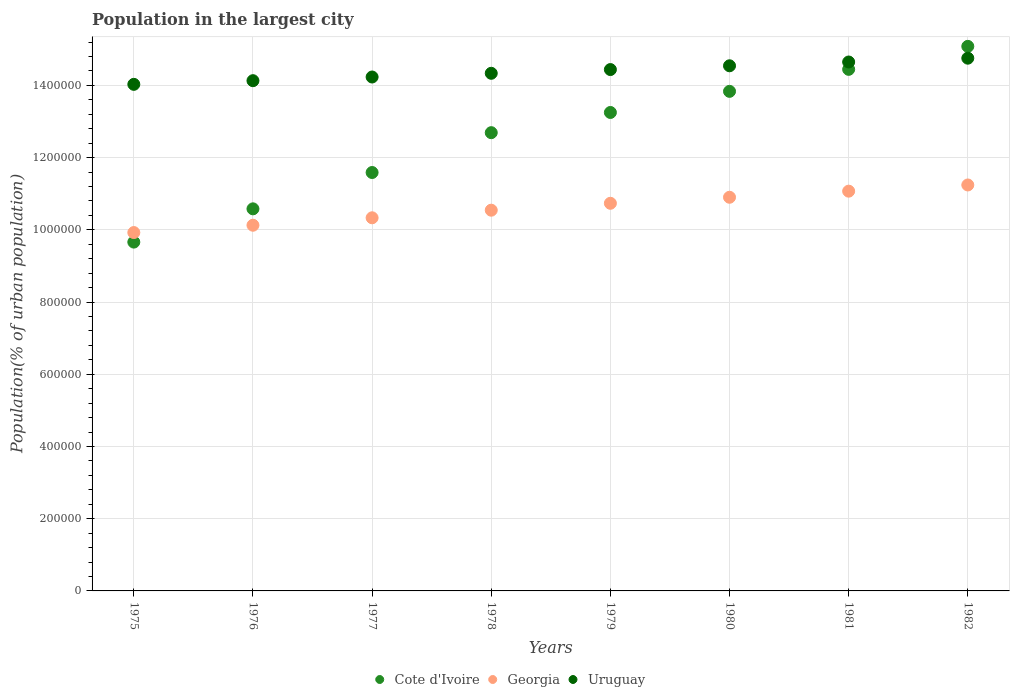How many different coloured dotlines are there?
Your answer should be very brief. 3. What is the population in the largest city in Cote d'Ivoire in 1977?
Offer a terse response. 1.16e+06. Across all years, what is the maximum population in the largest city in Georgia?
Keep it short and to the point. 1.12e+06. Across all years, what is the minimum population in the largest city in Georgia?
Keep it short and to the point. 9.92e+05. In which year was the population in the largest city in Cote d'Ivoire maximum?
Provide a succinct answer. 1982. In which year was the population in the largest city in Cote d'Ivoire minimum?
Ensure brevity in your answer.  1975. What is the total population in the largest city in Georgia in the graph?
Make the answer very short. 8.49e+06. What is the difference between the population in the largest city in Cote d'Ivoire in 1977 and that in 1980?
Offer a terse response. -2.25e+05. What is the difference between the population in the largest city in Cote d'Ivoire in 1979 and the population in the largest city in Georgia in 1975?
Offer a terse response. 3.33e+05. What is the average population in the largest city in Cote d'Ivoire per year?
Offer a terse response. 1.26e+06. In the year 1975, what is the difference between the population in the largest city in Cote d'Ivoire and population in the largest city in Georgia?
Your answer should be compact. -2.64e+04. What is the ratio of the population in the largest city in Uruguay in 1979 to that in 1980?
Offer a very short reply. 0.99. What is the difference between the highest and the second highest population in the largest city in Cote d'Ivoire?
Provide a short and direct response. 6.37e+04. What is the difference between the highest and the lowest population in the largest city in Georgia?
Provide a succinct answer. 1.32e+05. In how many years, is the population in the largest city in Cote d'Ivoire greater than the average population in the largest city in Cote d'Ivoire taken over all years?
Give a very brief answer. 5. Is the sum of the population in the largest city in Uruguay in 1975 and 1980 greater than the maximum population in the largest city in Georgia across all years?
Offer a very short reply. Yes. Is it the case that in every year, the sum of the population in the largest city in Cote d'Ivoire and population in the largest city in Uruguay  is greater than the population in the largest city in Georgia?
Your answer should be very brief. Yes. Does the population in the largest city in Uruguay monotonically increase over the years?
Offer a very short reply. Yes. Is the population in the largest city in Uruguay strictly greater than the population in the largest city in Cote d'Ivoire over the years?
Provide a short and direct response. No. How many years are there in the graph?
Make the answer very short. 8. Does the graph contain any zero values?
Offer a terse response. No. Does the graph contain grids?
Your answer should be compact. Yes. Where does the legend appear in the graph?
Offer a terse response. Bottom center. What is the title of the graph?
Provide a short and direct response. Population in the largest city. What is the label or title of the Y-axis?
Provide a short and direct response. Population(% of urban population). What is the Population(% of urban population) in Cote d'Ivoire in 1975?
Keep it short and to the point. 9.66e+05. What is the Population(% of urban population) of Georgia in 1975?
Keep it short and to the point. 9.92e+05. What is the Population(% of urban population) of Uruguay in 1975?
Provide a succinct answer. 1.40e+06. What is the Population(% of urban population) of Cote d'Ivoire in 1976?
Your answer should be very brief. 1.06e+06. What is the Population(% of urban population) in Georgia in 1976?
Keep it short and to the point. 1.01e+06. What is the Population(% of urban population) of Uruguay in 1976?
Your answer should be compact. 1.41e+06. What is the Population(% of urban population) in Cote d'Ivoire in 1977?
Provide a succinct answer. 1.16e+06. What is the Population(% of urban population) of Georgia in 1977?
Give a very brief answer. 1.03e+06. What is the Population(% of urban population) in Uruguay in 1977?
Your answer should be compact. 1.42e+06. What is the Population(% of urban population) in Cote d'Ivoire in 1978?
Provide a short and direct response. 1.27e+06. What is the Population(% of urban population) of Georgia in 1978?
Offer a very short reply. 1.05e+06. What is the Population(% of urban population) in Uruguay in 1978?
Ensure brevity in your answer.  1.43e+06. What is the Population(% of urban population) in Cote d'Ivoire in 1979?
Provide a succinct answer. 1.33e+06. What is the Population(% of urban population) of Georgia in 1979?
Your response must be concise. 1.07e+06. What is the Population(% of urban population) of Uruguay in 1979?
Ensure brevity in your answer.  1.44e+06. What is the Population(% of urban population) of Cote d'Ivoire in 1980?
Your response must be concise. 1.38e+06. What is the Population(% of urban population) in Georgia in 1980?
Offer a terse response. 1.09e+06. What is the Population(% of urban population) of Uruguay in 1980?
Give a very brief answer. 1.45e+06. What is the Population(% of urban population) in Cote d'Ivoire in 1981?
Provide a succinct answer. 1.44e+06. What is the Population(% of urban population) in Georgia in 1981?
Your answer should be compact. 1.11e+06. What is the Population(% of urban population) in Uruguay in 1981?
Keep it short and to the point. 1.46e+06. What is the Population(% of urban population) of Cote d'Ivoire in 1982?
Your answer should be very brief. 1.51e+06. What is the Population(% of urban population) of Georgia in 1982?
Offer a very short reply. 1.12e+06. What is the Population(% of urban population) of Uruguay in 1982?
Keep it short and to the point. 1.48e+06. Across all years, what is the maximum Population(% of urban population) in Cote d'Ivoire?
Your response must be concise. 1.51e+06. Across all years, what is the maximum Population(% of urban population) in Georgia?
Your answer should be compact. 1.12e+06. Across all years, what is the maximum Population(% of urban population) of Uruguay?
Give a very brief answer. 1.48e+06. Across all years, what is the minimum Population(% of urban population) in Cote d'Ivoire?
Provide a succinct answer. 9.66e+05. Across all years, what is the minimum Population(% of urban population) of Georgia?
Your answer should be very brief. 9.92e+05. Across all years, what is the minimum Population(% of urban population) in Uruguay?
Offer a very short reply. 1.40e+06. What is the total Population(% of urban population) of Cote d'Ivoire in the graph?
Make the answer very short. 1.01e+07. What is the total Population(% of urban population) in Georgia in the graph?
Your response must be concise. 8.49e+06. What is the total Population(% of urban population) of Uruguay in the graph?
Provide a succinct answer. 1.15e+07. What is the difference between the Population(% of urban population) of Cote d'Ivoire in 1975 and that in 1976?
Offer a very short reply. -9.21e+04. What is the difference between the Population(% of urban population) in Georgia in 1975 and that in 1976?
Your answer should be compact. -2.03e+04. What is the difference between the Population(% of urban population) in Uruguay in 1975 and that in 1976?
Your response must be concise. -1.01e+04. What is the difference between the Population(% of urban population) in Cote d'Ivoire in 1975 and that in 1977?
Provide a short and direct response. -1.93e+05. What is the difference between the Population(% of urban population) in Georgia in 1975 and that in 1977?
Offer a terse response. -4.09e+04. What is the difference between the Population(% of urban population) in Uruguay in 1975 and that in 1977?
Offer a very short reply. -2.03e+04. What is the difference between the Population(% of urban population) of Cote d'Ivoire in 1975 and that in 1978?
Provide a short and direct response. -3.03e+05. What is the difference between the Population(% of urban population) in Georgia in 1975 and that in 1978?
Make the answer very short. -6.19e+04. What is the difference between the Population(% of urban population) of Uruguay in 1975 and that in 1978?
Offer a very short reply. -3.06e+04. What is the difference between the Population(% of urban population) in Cote d'Ivoire in 1975 and that in 1979?
Provide a short and direct response. -3.59e+05. What is the difference between the Population(% of urban population) in Georgia in 1975 and that in 1979?
Provide a succinct answer. -8.11e+04. What is the difference between the Population(% of urban population) in Uruguay in 1975 and that in 1979?
Your answer should be compact. -4.09e+04. What is the difference between the Population(% of urban population) in Cote d'Ivoire in 1975 and that in 1980?
Your response must be concise. -4.17e+05. What is the difference between the Population(% of urban population) in Georgia in 1975 and that in 1980?
Make the answer very short. -9.77e+04. What is the difference between the Population(% of urban population) of Uruguay in 1975 and that in 1980?
Ensure brevity in your answer.  -5.14e+04. What is the difference between the Population(% of urban population) of Cote d'Ivoire in 1975 and that in 1981?
Provide a short and direct response. -4.78e+05. What is the difference between the Population(% of urban population) in Georgia in 1975 and that in 1981?
Offer a very short reply. -1.15e+05. What is the difference between the Population(% of urban population) in Uruguay in 1975 and that in 1981?
Your answer should be compact. -6.19e+04. What is the difference between the Population(% of urban population) of Cote d'Ivoire in 1975 and that in 1982?
Offer a terse response. -5.42e+05. What is the difference between the Population(% of urban population) of Georgia in 1975 and that in 1982?
Keep it short and to the point. -1.32e+05. What is the difference between the Population(% of urban population) in Uruguay in 1975 and that in 1982?
Provide a short and direct response. -7.24e+04. What is the difference between the Population(% of urban population) in Cote d'Ivoire in 1976 and that in 1977?
Provide a short and direct response. -1.01e+05. What is the difference between the Population(% of urban population) in Georgia in 1976 and that in 1977?
Give a very brief answer. -2.06e+04. What is the difference between the Population(% of urban population) of Uruguay in 1976 and that in 1977?
Offer a very short reply. -1.02e+04. What is the difference between the Population(% of urban population) of Cote d'Ivoire in 1976 and that in 1978?
Keep it short and to the point. -2.11e+05. What is the difference between the Population(% of urban population) in Georgia in 1976 and that in 1978?
Keep it short and to the point. -4.17e+04. What is the difference between the Population(% of urban population) of Uruguay in 1976 and that in 1978?
Give a very brief answer. -2.05e+04. What is the difference between the Population(% of urban population) of Cote d'Ivoire in 1976 and that in 1979?
Make the answer very short. -2.67e+05. What is the difference between the Population(% of urban population) of Georgia in 1976 and that in 1979?
Offer a terse response. -6.08e+04. What is the difference between the Population(% of urban population) of Uruguay in 1976 and that in 1979?
Give a very brief answer. -3.08e+04. What is the difference between the Population(% of urban population) of Cote d'Ivoire in 1976 and that in 1980?
Provide a short and direct response. -3.25e+05. What is the difference between the Population(% of urban population) of Georgia in 1976 and that in 1980?
Provide a succinct answer. -7.75e+04. What is the difference between the Population(% of urban population) of Uruguay in 1976 and that in 1980?
Make the answer very short. -4.12e+04. What is the difference between the Population(% of urban population) of Cote d'Ivoire in 1976 and that in 1981?
Your response must be concise. -3.86e+05. What is the difference between the Population(% of urban population) in Georgia in 1976 and that in 1981?
Give a very brief answer. -9.44e+04. What is the difference between the Population(% of urban population) in Uruguay in 1976 and that in 1981?
Make the answer very short. -5.17e+04. What is the difference between the Population(% of urban population) in Cote d'Ivoire in 1976 and that in 1982?
Provide a succinct answer. -4.50e+05. What is the difference between the Population(% of urban population) of Georgia in 1976 and that in 1982?
Provide a short and direct response. -1.12e+05. What is the difference between the Population(% of urban population) in Uruguay in 1976 and that in 1982?
Your answer should be very brief. -6.23e+04. What is the difference between the Population(% of urban population) of Cote d'Ivoire in 1977 and that in 1978?
Provide a short and direct response. -1.10e+05. What is the difference between the Population(% of urban population) in Georgia in 1977 and that in 1978?
Provide a succinct answer. -2.11e+04. What is the difference between the Population(% of urban population) of Uruguay in 1977 and that in 1978?
Ensure brevity in your answer.  -1.03e+04. What is the difference between the Population(% of urban population) of Cote d'Ivoire in 1977 and that in 1979?
Ensure brevity in your answer.  -1.66e+05. What is the difference between the Population(% of urban population) of Georgia in 1977 and that in 1979?
Provide a succinct answer. -4.02e+04. What is the difference between the Population(% of urban population) in Uruguay in 1977 and that in 1979?
Ensure brevity in your answer.  -2.06e+04. What is the difference between the Population(% of urban population) in Cote d'Ivoire in 1977 and that in 1980?
Provide a succinct answer. -2.25e+05. What is the difference between the Population(% of urban population) in Georgia in 1977 and that in 1980?
Provide a short and direct response. -5.69e+04. What is the difference between the Population(% of urban population) of Uruguay in 1977 and that in 1980?
Your answer should be very brief. -3.11e+04. What is the difference between the Population(% of urban population) in Cote d'Ivoire in 1977 and that in 1981?
Make the answer very short. -2.86e+05. What is the difference between the Population(% of urban population) of Georgia in 1977 and that in 1981?
Ensure brevity in your answer.  -7.37e+04. What is the difference between the Population(% of urban population) of Uruguay in 1977 and that in 1981?
Provide a succinct answer. -4.15e+04. What is the difference between the Population(% of urban population) in Cote d'Ivoire in 1977 and that in 1982?
Keep it short and to the point. -3.49e+05. What is the difference between the Population(% of urban population) of Georgia in 1977 and that in 1982?
Ensure brevity in your answer.  -9.09e+04. What is the difference between the Population(% of urban population) of Uruguay in 1977 and that in 1982?
Keep it short and to the point. -5.21e+04. What is the difference between the Population(% of urban population) in Cote d'Ivoire in 1978 and that in 1979?
Provide a succinct answer. -5.60e+04. What is the difference between the Population(% of urban population) of Georgia in 1978 and that in 1979?
Give a very brief answer. -1.91e+04. What is the difference between the Population(% of urban population) in Uruguay in 1978 and that in 1979?
Keep it short and to the point. -1.03e+04. What is the difference between the Population(% of urban population) of Cote d'Ivoire in 1978 and that in 1980?
Ensure brevity in your answer.  -1.14e+05. What is the difference between the Population(% of urban population) of Georgia in 1978 and that in 1980?
Keep it short and to the point. -3.58e+04. What is the difference between the Population(% of urban population) in Uruguay in 1978 and that in 1980?
Make the answer very short. -2.08e+04. What is the difference between the Population(% of urban population) of Cote d'Ivoire in 1978 and that in 1981?
Offer a very short reply. -1.75e+05. What is the difference between the Population(% of urban population) of Georgia in 1978 and that in 1981?
Ensure brevity in your answer.  -5.27e+04. What is the difference between the Population(% of urban population) in Uruguay in 1978 and that in 1981?
Keep it short and to the point. -3.13e+04. What is the difference between the Population(% of urban population) of Cote d'Ivoire in 1978 and that in 1982?
Offer a terse response. -2.39e+05. What is the difference between the Population(% of urban population) in Georgia in 1978 and that in 1982?
Keep it short and to the point. -6.98e+04. What is the difference between the Population(% of urban population) of Uruguay in 1978 and that in 1982?
Your answer should be compact. -4.18e+04. What is the difference between the Population(% of urban population) in Cote d'Ivoire in 1979 and that in 1980?
Offer a terse response. -5.85e+04. What is the difference between the Population(% of urban population) in Georgia in 1979 and that in 1980?
Your response must be concise. -1.67e+04. What is the difference between the Population(% of urban population) in Uruguay in 1979 and that in 1980?
Provide a succinct answer. -1.04e+04. What is the difference between the Population(% of urban population) of Cote d'Ivoire in 1979 and that in 1981?
Provide a succinct answer. -1.19e+05. What is the difference between the Population(% of urban population) in Georgia in 1979 and that in 1981?
Make the answer very short. -3.35e+04. What is the difference between the Population(% of urban population) in Uruguay in 1979 and that in 1981?
Keep it short and to the point. -2.09e+04. What is the difference between the Population(% of urban population) in Cote d'Ivoire in 1979 and that in 1982?
Ensure brevity in your answer.  -1.83e+05. What is the difference between the Population(% of urban population) of Georgia in 1979 and that in 1982?
Your answer should be very brief. -5.07e+04. What is the difference between the Population(% of urban population) in Uruguay in 1979 and that in 1982?
Offer a terse response. -3.15e+04. What is the difference between the Population(% of urban population) in Cote d'Ivoire in 1980 and that in 1981?
Your answer should be compact. -6.09e+04. What is the difference between the Population(% of urban population) in Georgia in 1980 and that in 1981?
Make the answer very short. -1.69e+04. What is the difference between the Population(% of urban population) of Uruguay in 1980 and that in 1981?
Offer a terse response. -1.05e+04. What is the difference between the Population(% of urban population) of Cote d'Ivoire in 1980 and that in 1982?
Give a very brief answer. -1.25e+05. What is the difference between the Population(% of urban population) in Georgia in 1980 and that in 1982?
Ensure brevity in your answer.  -3.40e+04. What is the difference between the Population(% of urban population) of Uruguay in 1980 and that in 1982?
Provide a succinct answer. -2.11e+04. What is the difference between the Population(% of urban population) in Cote d'Ivoire in 1981 and that in 1982?
Offer a terse response. -6.37e+04. What is the difference between the Population(% of urban population) in Georgia in 1981 and that in 1982?
Offer a very short reply. -1.72e+04. What is the difference between the Population(% of urban population) in Uruguay in 1981 and that in 1982?
Provide a short and direct response. -1.06e+04. What is the difference between the Population(% of urban population) of Cote d'Ivoire in 1975 and the Population(% of urban population) of Georgia in 1976?
Make the answer very short. -4.67e+04. What is the difference between the Population(% of urban population) of Cote d'Ivoire in 1975 and the Population(% of urban population) of Uruguay in 1976?
Provide a succinct answer. -4.47e+05. What is the difference between the Population(% of urban population) in Georgia in 1975 and the Population(% of urban population) in Uruguay in 1976?
Your answer should be very brief. -4.21e+05. What is the difference between the Population(% of urban population) of Cote d'Ivoire in 1975 and the Population(% of urban population) of Georgia in 1977?
Ensure brevity in your answer.  -6.73e+04. What is the difference between the Population(% of urban population) of Cote d'Ivoire in 1975 and the Population(% of urban population) of Uruguay in 1977?
Give a very brief answer. -4.57e+05. What is the difference between the Population(% of urban population) of Georgia in 1975 and the Population(% of urban population) of Uruguay in 1977?
Your response must be concise. -4.31e+05. What is the difference between the Population(% of urban population) of Cote d'Ivoire in 1975 and the Population(% of urban population) of Georgia in 1978?
Your response must be concise. -8.84e+04. What is the difference between the Population(% of urban population) in Cote d'Ivoire in 1975 and the Population(% of urban population) in Uruguay in 1978?
Ensure brevity in your answer.  -4.67e+05. What is the difference between the Population(% of urban population) of Georgia in 1975 and the Population(% of urban population) of Uruguay in 1978?
Your answer should be very brief. -4.41e+05. What is the difference between the Population(% of urban population) in Cote d'Ivoire in 1975 and the Population(% of urban population) in Georgia in 1979?
Ensure brevity in your answer.  -1.08e+05. What is the difference between the Population(% of urban population) of Cote d'Ivoire in 1975 and the Population(% of urban population) of Uruguay in 1979?
Ensure brevity in your answer.  -4.78e+05. What is the difference between the Population(% of urban population) in Georgia in 1975 and the Population(% of urban population) in Uruguay in 1979?
Your answer should be very brief. -4.51e+05. What is the difference between the Population(% of urban population) of Cote d'Ivoire in 1975 and the Population(% of urban population) of Georgia in 1980?
Give a very brief answer. -1.24e+05. What is the difference between the Population(% of urban population) in Cote d'Ivoire in 1975 and the Population(% of urban population) in Uruguay in 1980?
Make the answer very short. -4.88e+05. What is the difference between the Population(% of urban population) in Georgia in 1975 and the Population(% of urban population) in Uruguay in 1980?
Offer a terse response. -4.62e+05. What is the difference between the Population(% of urban population) in Cote d'Ivoire in 1975 and the Population(% of urban population) in Georgia in 1981?
Your answer should be compact. -1.41e+05. What is the difference between the Population(% of urban population) in Cote d'Ivoire in 1975 and the Population(% of urban population) in Uruguay in 1981?
Ensure brevity in your answer.  -4.99e+05. What is the difference between the Population(% of urban population) of Georgia in 1975 and the Population(% of urban population) of Uruguay in 1981?
Keep it short and to the point. -4.72e+05. What is the difference between the Population(% of urban population) in Cote d'Ivoire in 1975 and the Population(% of urban population) in Georgia in 1982?
Ensure brevity in your answer.  -1.58e+05. What is the difference between the Population(% of urban population) in Cote d'Ivoire in 1975 and the Population(% of urban population) in Uruguay in 1982?
Ensure brevity in your answer.  -5.09e+05. What is the difference between the Population(% of urban population) of Georgia in 1975 and the Population(% of urban population) of Uruguay in 1982?
Keep it short and to the point. -4.83e+05. What is the difference between the Population(% of urban population) in Cote d'Ivoire in 1976 and the Population(% of urban population) in Georgia in 1977?
Give a very brief answer. 2.48e+04. What is the difference between the Population(% of urban population) in Cote d'Ivoire in 1976 and the Population(% of urban population) in Uruguay in 1977?
Make the answer very short. -3.65e+05. What is the difference between the Population(% of urban population) of Georgia in 1976 and the Population(% of urban population) of Uruguay in 1977?
Keep it short and to the point. -4.11e+05. What is the difference between the Population(% of urban population) in Cote d'Ivoire in 1976 and the Population(% of urban population) in Georgia in 1978?
Provide a succinct answer. 3739. What is the difference between the Population(% of urban population) of Cote d'Ivoire in 1976 and the Population(% of urban population) of Uruguay in 1978?
Your answer should be very brief. -3.75e+05. What is the difference between the Population(% of urban population) in Georgia in 1976 and the Population(% of urban population) in Uruguay in 1978?
Your answer should be compact. -4.21e+05. What is the difference between the Population(% of urban population) of Cote d'Ivoire in 1976 and the Population(% of urban population) of Georgia in 1979?
Offer a terse response. -1.54e+04. What is the difference between the Population(% of urban population) of Cote d'Ivoire in 1976 and the Population(% of urban population) of Uruguay in 1979?
Give a very brief answer. -3.86e+05. What is the difference between the Population(% of urban population) in Georgia in 1976 and the Population(% of urban population) in Uruguay in 1979?
Offer a very short reply. -4.31e+05. What is the difference between the Population(% of urban population) of Cote d'Ivoire in 1976 and the Population(% of urban population) of Georgia in 1980?
Provide a succinct answer. -3.21e+04. What is the difference between the Population(% of urban population) in Cote d'Ivoire in 1976 and the Population(% of urban population) in Uruguay in 1980?
Give a very brief answer. -3.96e+05. What is the difference between the Population(% of urban population) of Georgia in 1976 and the Population(% of urban population) of Uruguay in 1980?
Make the answer very short. -4.42e+05. What is the difference between the Population(% of urban population) in Cote d'Ivoire in 1976 and the Population(% of urban population) in Georgia in 1981?
Offer a very short reply. -4.89e+04. What is the difference between the Population(% of urban population) in Cote d'Ivoire in 1976 and the Population(% of urban population) in Uruguay in 1981?
Ensure brevity in your answer.  -4.07e+05. What is the difference between the Population(% of urban population) of Georgia in 1976 and the Population(% of urban population) of Uruguay in 1981?
Provide a short and direct response. -4.52e+05. What is the difference between the Population(% of urban population) of Cote d'Ivoire in 1976 and the Population(% of urban population) of Georgia in 1982?
Offer a very short reply. -6.61e+04. What is the difference between the Population(% of urban population) in Cote d'Ivoire in 1976 and the Population(% of urban population) in Uruguay in 1982?
Make the answer very short. -4.17e+05. What is the difference between the Population(% of urban population) of Georgia in 1976 and the Population(% of urban population) of Uruguay in 1982?
Provide a short and direct response. -4.63e+05. What is the difference between the Population(% of urban population) of Cote d'Ivoire in 1977 and the Population(% of urban population) of Georgia in 1978?
Your response must be concise. 1.04e+05. What is the difference between the Population(% of urban population) in Cote d'Ivoire in 1977 and the Population(% of urban population) in Uruguay in 1978?
Offer a terse response. -2.75e+05. What is the difference between the Population(% of urban population) in Georgia in 1977 and the Population(% of urban population) in Uruguay in 1978?
Your answer should be very brief. -4.00e+05. What is the difference between the Population(% of urban population) of Cote d'Ivoire in 1977 and the Population(% of urban population) of Georgia in 1979?
Keep it short and to the point. 8.52e+04. What is the difference between the Population(% of urban population) in Cote d'Ivoire in 1977 and the Population(% of urban population) in Uruguay in 1979?
Keep it short and to the point. -2.85e+05. What is the difference between the Population(% of urban population) of Georgia in 1977 and the Population(% of urban population) of Uruguay in 1979?
Keep it short and to the point. -4.11e+05. What is the difference between the Population(% of urban population) of Cote d'Ivoire in 1977 and the Population(% of urban population) of Georgia in 1980?
Offer a terse response. 6.85e+04. What is the difference between the Population(% of urban population) of Cote d'Ivoire in 1977 and the Population(% of urban population) of Uruguay in 1980?
Make the answer very short. -2.96e+05. What is the difference between the Population(% of urban population) of Georgia in 1977 and the Population(% of urban population) of Uruguay in 1980?
Provide a succinct answer. -4.21e+05. What is the difference between the Population(% of urban population) in Cote d'Ivoire in 1977 and the Population(% of urban population) in Georgia in 1981?
Your answer should be very brief. 5.17e+04. What is the difference between the Population(% of urban population) in Cote d'Ivoire in 1977 and the Population(% of urban population) in Uruguay in 1981?
Provide a succinct answer. -3.06e+05. What is the difference between the Population(% of urban population) of Georgia in 1977 and the Population(% of urban population) of Uruguay in 1981?
Your answer should be compact. -4.31e+05. What is the difference between the Population(% of urban population) in Cote d'Ivoire in 1977 and the Population(% of urban population) in Georgia in 1982?
Provide a short and direct response. 3.45e+04. What is the difference between the Population(% of urban population) of Cote d'Ivoire in 1977 and the Population(% of urban population) of Uruguay in 1982?
Keep it short and to the point. -3.17e+05. What is the difference between the Population(% of urban population) in Georgia in 1977 and the Population(% of urban population) in Uruguay in 1982?
Ensure brevity in your answer.  -4.42e+05. What is the difference between the Population(% of urban population) of Cote d'Ivoire in 1978 and the Population(% of urban population) of Georgia in 1979?
Ensure brevity in your answer.  1.96e+05. What is the difference between the Population(% of urban population) in Cote d'Ivoire in 1978 and the Population(% of urban population) in Uruguay in 1979?
Provide a succinct answer. -1.75e+05. What is the difference between the Population(% of urban population) of Georgia in 1978 and the Population(% of urban population) of Uruguay in 1979?
Offer a very short reply. -3.89e+05. What is the difference between the Population(% of urban population) in Cote d'Ivoire in 1978 and the Population(% of urban population) in Georgia in 1980?
Offer a very short reply. 1.79e+05. What is the difference between the Population(% of urban population) of Cote d'Ivoire in 1978 and the Population(% of urban population) of Uruguay in 1980?
Offer a very short reply. -1.85e+05. What is the difference between the Population(% of urban population) in Georgia in 1978 and the Population(% of urban population) in Uruguay in 1980?
Ensure brevity in your answer.  -4.00e+05. What is the difference between the Population(% of urban population) of Cote d'Ivoire in 1978 and the Population(% of urban population) of Georgia in 1981?
Provide a short and direct response. 1.62e+05. What is the difference between the Population(% of urban population) in Cote d'Ivoire in 1978 and the Population(% of urban population) in Uruguay in 1981?
Make the answer very short. -1.96e+05. What is the difference between the Population(% of urban population) of Georgia in 1978 and the Population(% of urban population) of Uruguay in 1981?
Make the answer very short. -4.10e+05. What is the difference between the Population(% of urban population) of Cote d'Ivoire in 1978 and the Population(% of urban population) of Georgia in 1982?
Offer a terse response. 1.45e+05. What is the difference between the Population(% of urban population) in Cote d'Ivoire in 1978 and the Population(% of urban population) in Uruguay in 1982?
Your answer should be compact. -2.06e+05. What is the difference between the Population(% of urban population) in Georgia in 1978 and the Population(% of urban population) in Uruguay in 1982?
Give a very brief answer. -4.21e+05. What is the difference between the Population(% of urban population) of Cote d'Ivoire in 1979 and the Population(% of urban population) of Georgia in 1980?
Provide a succinct answer. 2.35e+05. What is the difference between the Population(% of urban population) of Cote d'Ivoire in 1979 and the Population(% of urban population) of Uruguay in 1980?
Provide a short and direct response. -1.29e+05. What is the difference between the Population(% of urban population) of Georgia in 1979 and the Population(% of urban population) of Uruguay in 1980?
Provide a short and direct response. -3.81e+05. What is the difference between the Population(% of urban population) of Cote d'Ivoire in 1979 and the Population(% of urban population) of Georgia in 1981?
Your response must be concise. 2.18e+05. What is the difference between the Population(% of urban population) of Cote d'Ivoire in 1979 and the Population(% of urban population) of Uruguay in 1981?
Your response must be concise. -1.40e+05. What is the difference between the Population(% of urban population) of Georgia in 1979 and the Population(% of urban population) of Uruguay in 1981?
Ensure brevity in your answer.  -3.91e+05. What is the difference between the Population(% of urban population) of Cote d'Ivoire in 1979 and the Population(% of urban population) of Georgia in 1982?
Give a very brief answer. 2.01e+05. What is the difference between the Population(% of urban population) in Cote d'Ivoire in 1979 and the Population(% of urban population) in Uruguay in 1982?
Keep it short and to the point. -1.50e+05. What is the difference between the Population(% of urban population) of Georgia in 1979 and the Population(% of urban population) of Uruguay in 1982?
Offer a very short reply. -4.02e+05. What is the difference between the Population(% of urban population) of Cote d'Ivoire in 1980 and the Population(% of urban population) of Georgia in 1981?
Your answer should be very brief. 2.76e+05. What is the difference between the Population(% of urban population) in Cote d'Ivoire in 1980 and the Population(% of urban population) in Uruguay in 1981?
Provide a short and direct response. -8.13e+04. What is the difference between the Population(% of urban population) in Georgia in 1980 and the Population(% of urban population) in Uruguay in 1981?
Keep it short and to the point. -3.75e+05. What is the difference between the Population(% of urban population) in Cote d'Ivoire in 1980 and the Population(% of urban population) in Georgia in 1982?
Ensure brevity in your answer.  2.59e+05. What is the difference between the Population(% of urban population) of Cote d'Ivoire in 1980 and the Population(% of urban population) of Uruguay in 1982?
Ensure brevity in your answer.  -9.18e+04. What is the difference between the Population(% of urban population) of Georgia in 1980 and the Population(% of urban population) of Uruguay in 1982?
Offer a very short reply. -3.85e+05. What is the difference between the Population(% of urban population) of Cote d'Ivoire in 1981 and the Population(% of urban population) of Georgia in 1982?
Offer a very short reply. 3.20e+05. What is the difference between the Population(% of urban population) of Cote d'Ivoire in 1981 and the Population(% of urban population) of Uruguay in 1982?
Offer a terse response. -3.09e+04. What is the difference between the Population(% of urban population) in Georgia in 1981 and the Population(% of urban population) in Uruguay in 1982?
Keep it short and to the point. -3.68e+05. What is the average Population(% of urban population) in Cote d'Ivoire per year?
Make the answer very short. 1.26e+06. What is the average Population(% of urban population) in Georgia per year?
Offer a terse response. 1.06e+06. What is the average Population(% of urban population) of Uruguay per year?
Offer a terse response. 1.44e+06. In the year 1975, what is the difference between the Population(% of urban population) in Cote d'Ivoire and Population(% of urban population) in Georgia?
Provide a short and direct response. -2.64e+04. In the year 1975, what is the difference between the Population(% of urban population) of Cote d'Ivoire and Population(% of urban population) of Uruguay?
Keep it short and to the point. -4.37e+05. In the year 1975, what is the difference between the Population(% of urban population) in Georgia and Population(% of urban population) in Uruguay?
Keep it short and to the point. -4.10e+05. In the year 1976, what is the difference between the Population(% of urban population) of Cote d'Ivoire and Population(% of urban population) of Georgia?
Keep it short and to the point. 4.54e+04. In the year 1976, what is the difference between the Population(% of urban population) of Cote d'Ivoire and Population(% of urban population) of Uruguay?
Offer a very short reply. -3.55e+05. In the year 1976, what is the difference between the Population(% of urban population) in Georgia and Population(% of urban population) in Uruguay?
Offer a terse response. -4.00e+05. In the year 1977, what is the difference between the Population(% of urban population) in Cote d'Ivoire and Population(% of urban population) in Georgia?
Provide a succinct answer. 1.25e+05. In the year 1977, what is the difference between the Population(% of urban population) of Cote d'Ivoire and Population(% of urban population) of Uruguay?
Your answer should be very brief. -2.64e+05. In the year 1977, what is the difference between the Population(% of urban population) in Georgia and Population(% of urban population) in Uruguay?
Provide a short and direct response. -3.90e+05. In the year 1978, what is the difference between the Population(% of urban population) in Cote d'Ivoire and Population(% of urban population) in Georgia?
Make the answer very short. 2.15e+05. In the year 1978, what is the difference between the Population(% of urban population) of Cote d'Ivoire and Population(% of urban population) of Uruguay?
Offer a terse response. -1.64e+05. In the year 1978, what is the difference between the Population(% of urban population) in Georgia and Population(% of urban population) in Uruguay?
Provide a short and direct response. -3.79e+05. In the year 1979, what is the difference between the Population(% of urban population) in Cote d'Ivoire and Population(% of urban population) in Georgia?
Offer a very short reply. 2.51e+05. In the year 1979, what is the difference between the Population(% of urban population) of Cote d'Ivoire and Population(% of urban population) of Uruguay?
Make the answer very short. -1.19e+05. In the year 1979, what is the difference between the Population(% of urban population) of Georgia and Population(% of urban population) of Uruguay?
Make the answer very short. -3.70e+05. In the year 1980, what is the difference between the Population(% of urban population) in Cote d'Ivoire and Population(% of urban population) in Georgia?
Keep it short and to the point. 2.93e+05. In the year 1980, what is the difference between the Population(% of urban population) of Cote d'Ivoire and Population(% of urban population) of Uruguay?
Give a very brief answer. -7.08e+04. In the year 1980, what is the difference between the Population(% of urban population) in Georgia and Population(% of urban population) in Uruguay?
Offer a very short reply. -3.64e+05. In the year 1981, what is the difference between the Population(% of urban population) in Cote d'Ivoire and Population(% of urban population) in Georgia?
Provide a short and direct response. 3.37e+05. In the year 1981, what is the difference between the Population(% of urban population) of Cote d'Ivoire and Population(% of urban population) of Uruguay?
Your response must be concise. -2.04e+04. In the year 1981, what is the difference between the Population(% of urban population) of Georgia and Population(% of urban population) of Uruguay?
Keep it short and to the point. -3.58e+05. In the year 1982, what is the difference between the Population(% of urban population) of Cote d'Ivoire and Population(% of urban population) of Georgia?
Offer a terse response. 3.84e+05. In the year 1982, what is the difference between the Population(% of urban population) of Cote d'Ivoire and Population(% of urban population) of Uruguay?
Ensure brevity in your answer.  3.28e+04. In the year 1982, what is the difference between the Population(% of urban population) in Georgia and Population(% of urban population) in Uruguay?
Make the answer very short. -3.51e+05. What is the ratio of the Population(% of urban population) of Cote d'Ivoire in 1975 to that in 1976?
Ensure brevity in your answer.  0.91. What is the ratio of the Population(% of urban population) of Uruguay in 1975 to that in 1976?
Offer a terse response. 0.99. What is the ratio of the Population(% of urban population) of Cote d'Ivoire in 1975 to that in 1977?
Give a very brief answer. 0.83. What is the ratio of the Population(% of urban population) of Georgia in 1975 to that in 1977?
Keep it short and to the point. 0.96. What is the ratio of the Population(% of urban population) of Uruguay in 1975 to that in 1977?
Your response must be concise. 0.99. What is the ratio of the Population(% of urban population) in Cote d'Ivoire in 1975 to that in 1978?
Ensure brevity in your answer.  0.76. What is the ratio of the Population(% of urban population) in Georgia in 1975 to that in 1978?
Offer a terse response. 0.94. What is the ratio of the Population(% of urban population) in Uruguay in 1975 to that in 1978?
Your answer should be very brief. 0.98. What is the ratio of the Population(% of urban population) of Cote d'Ivoire in 1975 to that in 1979?
Offer a very short reply. 0.73. What is the ratio of the Population(% of urban population) in Georgia in 1975 to that in 1979?
Keep it short and to the point. 0.92. What is the ratio of the Population(% of urban population) of Uruguay in 1975 to that in 1979?
Ensure brevity in your answer.  0.97. What is the ratio of the Population(% of urban population) of Cote d'Ivoire in 1975 to that in 1980?
Your answer should be compact. 0.7. What is the ratio of the Population(% of urban population) in Georgia in 1975 to that in 1980?
Offer a very short reply. 0.91. What is the ratio of the Population(% of urban population) of Uruguay in 1975 to that in 1980?
Offer a very short reply. 0.96. What is the ratio of the Population(% of urban population) of Cote d'Ivoire in 1975 to that in 1981?
Offer a terse response. 0.67. What is the ratio of the Population(% of urban population) of Georgia in 1975 to that in 1981?
Give a very brief answer. 0.9. What is the ratio of the Population(% of urban population) in Uruguay in 1975 to that in 1981?
Ensure brevity in your answer.  0.96. What is the ratio of the Population(% of urban population) of Cote d'Ivoire in 1975 to that in 1982?
Give a very brief answer. 0.64. What is the ratio of the Population(% of urban population) in Georgia in 1975 to that in 1982?
Provide a short and direct response. 0.88. What is the ratio of the Population(% of urban population) in Uruguay in 1975 to that in 1982?
Your answer should be very brief. 0.95. What is the ratio of the Population(% of urban population) of Cote d'Ivoire in 1976 to that in 1977?
Your answer should be compact. 0.91. What is the ratio of the Population(% of urban population) of Georgia in 1976 to that in 1977?
Your answer should be very brief. 0.98. What is the ratio of the Population(% of urban population) of Cote d'Ivoire in 1976 to that in 1978?
Give a very brief answer. 0.83. What is the ratio of the Population(% of urban population) of Georgia in 1976 to that in 1978?
Keep it short and to the point. 0.96. What is the ratio of the Population(% of urban population) of Uruguay in 1976 to that in 1978?
Ensure brevity in your answer.  0.99. What is the ratio of the Population(% of urban population) in Cote d'Ivoire in 1976 to that in 1979?
Offer a terse response. 0.8. What is the ratio of the Population(% of urban population) in Georgia in 1976 to that in 1979?
Provide a short and direct response. 0.94. What is the ratio of the Population(% of urban population) in Uruguay in 1976 to that in 1979?
Keep it short and to the point. 0.98. What is the ratio of the Population(% of urban population) in Cote d'Ivoire in 1976 to that in 1980?
Offer a very short reply. 0.76. What is the ratio of the Population(% of urban population) in Georgia in 1976 to that in 1980?
Provide a succinct answer. 0.93. What is the ratio of the Population(% of urban population) in Uruguay in 1976 to that in 1980?
Make the answer very short. 0.97. What is the ratio of the Population(% of urban population) in Cote d'Ivoire in 1976 to that in 1981?
Offer a terse response. 0.73. What is the ratio of the Population(% of urban population) in Georgia in 1976 to that in 1981?
Give a very brief answer. 0.91. What is the ratio of the Population(% of urban population) in Uruguay in 1976 to that in 1981?
Make the answer very short. 0.96. What is the ratio of the Population(% of urban population) in Cote d'Ivoire in 1976 to that in 1982?
Offer a terse response. 0.7. What is the ratio of the Population(% of urban population) of Georgia in 1976 to that in 1982?
Offer a very short reply. 0.9. What is the ratio of the Population(% of urban population) in Uruguay in 1976 to that in 1982?
Your answer should be compact. 0.96. What is the ratio of the Population(% of urban population) in Cote d'Ivoire in 1977 to that in 1978?
Make the answer very short. 0.91. What is the ratio of the Population(% of urban population) in Uruguay in 1977 to that in 1978?
Provide a short and direct response. 0.99. What is the ratio of the Population(% of urban population) of Cote d'Ivoire in 1977 to that in 1979?
Make the answer very short. 0.87. What is the ratio of the Population(% of urban population) of Georgia in 1977 to that in 1979?
Your answer should be very brief. 0.96. What is the ratio of the Population(% of urban population) in Uruguay in 1977 to that in 1979?
Provide a short and direct response. 0.99. What is the ratio of the Population(% of urban population) in Cote d'Ivoire in 1977 to that in 1980?
Your answer should be very brief. 0.84. What is the ratio of the Population(% of urban population) in Georgia in 1977 to that in 1980?
Provide a short and direct response. 0.95. What is the ratio of the Population(% of urban population) of Uruguay in 1977 to that in 1980?
Provide a short and direct response. 0.98. What is the ratio of the Population(% of urban population) of Cote d'Ivoire in 1977 to that in 1981?
Offer a terse response. 0.8. What is the ratio of the Population(% of urban population) of Georgia in 1977 to that in 1981?
Provide a short and direct response. 0.93. What is the ratio of the Population(% of urban population) in Uruguay in 1977 to that in 1981?
Keep it short and to the point. 0.97. What is the ratio of the Population(% of urban population) of Cote d'Ivoire in 1977 to that in 1982?
Keep it short and to the point. 0.77. What is the ratio of the Population(% of urban population) in Georgia in 1977 to that in 1982?
Provide a succinct answer. 0.92. What is the ratio of the Population(% of urban population) in Uruguay in 1977 to that in 1982?
Make the answer very short. 0.96. What is the ratio of the Population(% of urban population) in Cote d'Ivoire in 1978 to that in 1979?
Give a very brief answer. 0.96. What is the ratio of the Population(% of urban population) of Georgia in 1978 to that in 1979?
Offer a terse response. 0.98. What is the ratio of the Population(% of urban population) in Cote d'Ivoire in 1978 to that in 1980?
Make the answer very short. 0.92. What is the ratio of the Population(% of urban population) of Georgia in 1978 to that in 1980?
Keep it short and to the point. 0.97. What is the ratio of the Population(% of urban population) of Uruguay in 1978 to that in 1980?
Your answer should be very brief. 0.99. What is the ratio of the Population(% of urban population) in Cote d'Ivoire in 1978 to that in 1981?
Make the answer very short. 0.88. What is the ratio of the Population(% of urban population) in Uruguay in 1978 to that in 1981?
Your answer should be compact. 0.98. What is the ratio of the Population(% of urban population) in Cote d'Ivoire in 1978 to that in 1982?
Ensure brevity in your answer.  0.84. What is the ratio of the Population(% of urban population) in Georgia in 1978 to that in 1982?
Your answer should be very brief. 0.94. What is the ratio of the Population(% of urban population) of Uruguay in 1978 to that in 1982?
Your response must be concise. 0.97. What is the ratio of the Population(% of urban population) of Cote d'Ivoire in 1979 to that in 1980?
Ensure brevity in your answer.  0.96. What is the ratio of the Population(% of urban population) of Georgia in 1979 to that in 1980?
Your answer should be very brief. 0.98. What is the ratio of the Population(% of urban population) in Uruguay in 1979 to that in 1980?
Offer a very short reply. 0.99. What is the ratio of the Population(% of urban population) of Cote d'Ivoire in 1979 to that in 1981?
Your answer should be compact. 0.92. What is the ratio of the Population(% of urban population) of Georgia in 1979 to that in 1981?
Give a very brief answer. 0.97. What is the ratio of the Population(% of urban population) of Uruguay in 1979 to that in 1981?
Offer a very short reply. 0.99. What is the ratio of the Population(% of urban population) of Cote d'Ivoire in 1979 to that in 1982?
Your answer should be compact. 0.88. What is the ratio of the Population(% of urban population) in Georgia in 1979 to that in 1982?
Provide a short and direct response. 0.95. What is the ratio of the Population(% of urban population) in Uruguay in 1979 to that in 1982?
Your answer should be compact. 0.98. What is the ratio of the Population(% of urban population) in Cote d'Ivoire in 1980 to that in 1981?
Make the answer very short. 0.96. What is the ratio of the Population(% of urban population) in Uruguay in 1980 to that in 1981?
Give a very brief answer. 0.99. What is the ratio of the Population(% of urban population) in Cote d'Ivoire in 1980 to that in 1982?
Your answer should be very brief. 0.92. What is the ratio of the Population(% of urban population) of Georgia in 1980 to that in 1982?
Keep it short and to the point. 0.97. What is the ratio of the Population(% of urban population) in Uruguay in 1980 to that in 1982?
Keep it short and to the point. 0.99. What is the ratio of the Population(% of urban population) of Cote d'Ivoire in 1981 to that in 1982?
Ensure brevity in your answer.  0.96. What is the ratio of the Population(% of urban population) of Georgia in 1981 to that in 1982?
Give a very brief answer. 0.98. What is the difference between the highest and the second highest Population(% of urban population) of Cote d'Ivoire?
Give a very brief answer. 6.37e+04. What is the difference between the highest and the second highest Population(% of urban population) of Georgia?
Your answer should be compact. 1.72e+04. What is the difference between the highest and the second highest Population(% of urban population) in Uruguay?
Offer a terse response. 1.06e+04. What is the difference between the highest and the lowest Population(% of urban population) in Cote d'Ivoire?
Make the answer very short. 5.42e+05. What is the difference between the highest and the lowest Population(% of urban population) in Georgia?
Give a very brief answer. 1.32e+05. What is the difference between the highest and the lowest Population(% of urban population) of Uruguay?
Provide a succinct answer. 7.24e+04. 